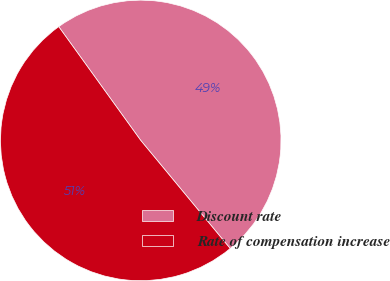<chart> <loc_0><loc_0><loc_500><loc_500><pie_chart><fcel>Discount rate<fcel>Rate of compensation increase<nl><fcel>48.94%<fcel>51.06%<nl></chart> 